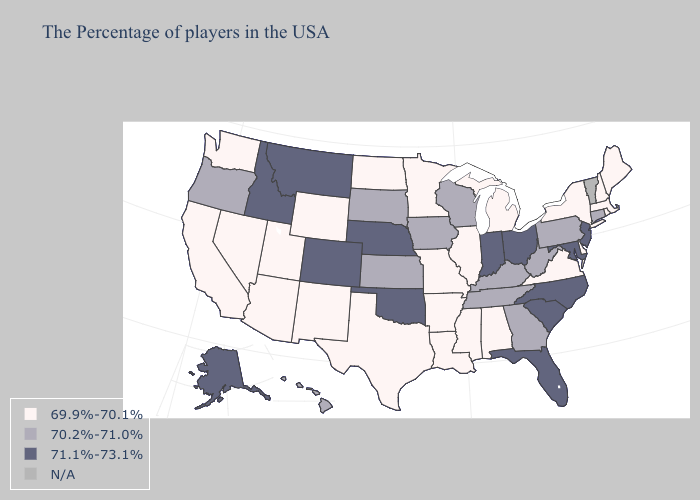Name the states that have a value in the range 70.2%-71.0%?
Give a very brief answer. Connecticut, Pennsylvania, West Virginia, Georgia, Kentucky, Tennessee, Wisconsin, Iowa, Kansas, South Dakota, Oregon, Hawaii. Name the states that have a value in the range N/A?
Concise answer only. Vermont. Does Alabama have the highest value in the USA?
Quick response, please. No. Which states have the lowest value in the South?
Short answer required. Delaware, Virginia, Alabama, Mississippi, Louisiana, Arkansas, Texas. Does the map have missing data?
Write a very short answer. Yes. What is the highest value in the USA?
Answer briefly. 71.1%-73.1%. Name the states that have a value in the range 71.1%-73.1%?
Write a very short answer. New Jersey, Maryland, North Carolina, South Carolina, Ohio, Florida, Indiana, Nebraska, Oklahoma, Colorado, Montana, Idaho, Alaska. What is the highest value in states that border Michigan?
Give a very brief answer. 71.1%-73.1%. What is the value of Nevada?
Concise answer only. 69.9%-70.1%. What is the value of Alaska?
Be succinct. 71.1%-73.1%. Among the states that border Maryland , which have the lowest value?
Be succinct. Delaware, Virginia. What is the value of Connecticut?
Answer briefly. 70.2%-71.0%. How many symbols are there in the legend?
Concise answer only. 4. Name the states that have a value in the range N/A?
Concise answer only. Vermont. 